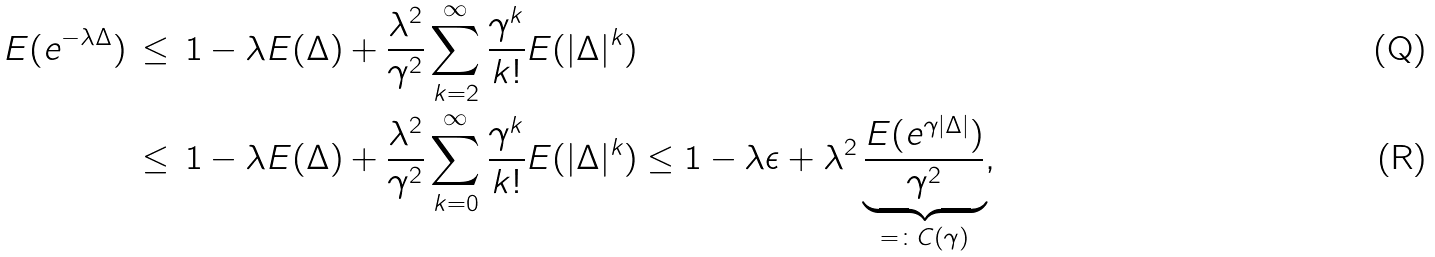<formula> <loc_0><loc_0><loc_500><loc_500>E ( e ^ { - \lambda \Delta } ) & \, \leq \, 1 - \lambda E ( \Delta ) + \frac { \lambda ^ { 2 } } { \gamma ^ { 2 } } \sum _ { k = 2 } ^ { \infty } \frac { \gamma ^ { k } } { k ! } E ( | \Delta | ^ { k } ) \\ & \, \leq \, 1 - \lambda E ( \Delta ) + \frac { \lambda ^ { 2 } } { \gamma ^ { 2 } } \sum _ { k = 0 } ^ { \infty } \frac { \gamma ^ { k } } { k ! } E ( | \Delta | ^ { k } ) \leq 1 - \lambda \epsilon + \lambda ^ { 2 } \underbrace { \frac { E ( e ^ { \gamma | \Delta | } ) } { \gamma ^ { 2 } } } _ { = \colon C ( \gamma ) } ,</formula> 